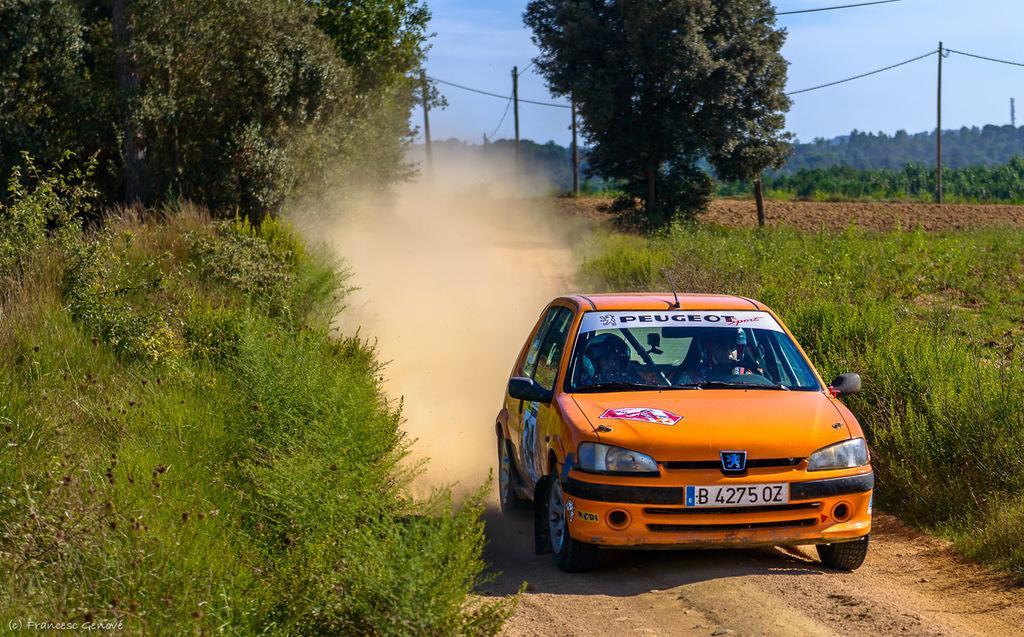How would you summarize this image in a sentence or two? On the left side of the picture there are plants, grass and trees. On the right there are shrubs, plants, fields, trees, cable and current polls. In the foreground there is a car on the road. Sky is clear and it is sunny. 